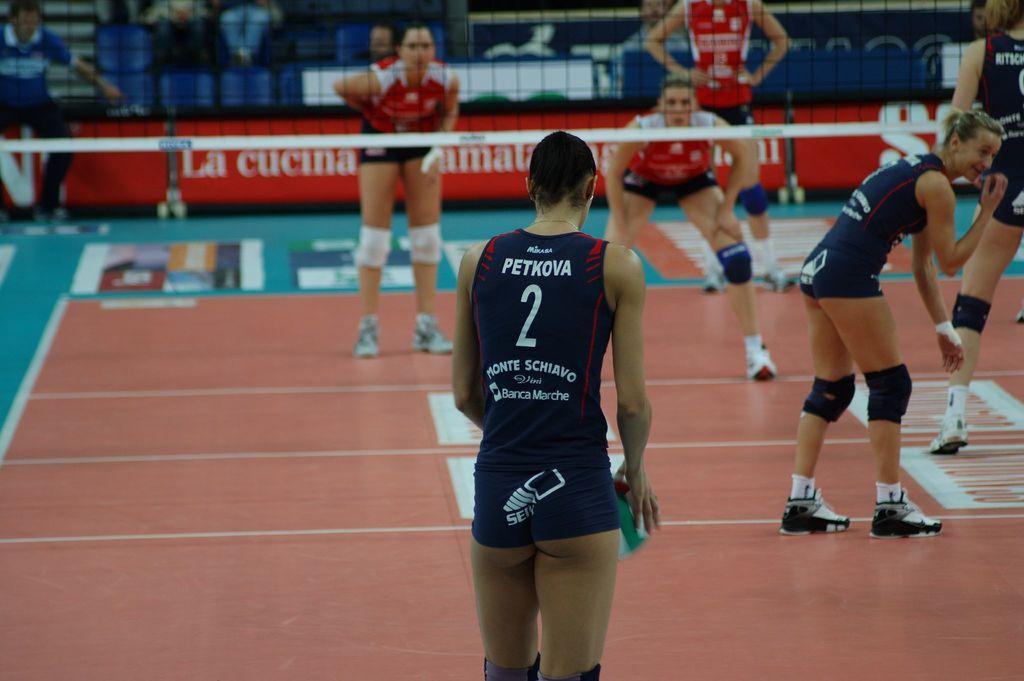Could you give a brief overview of what you see in this image? In this image we can see girls playing a sport in the stadium. There is a net. In the background of the image there is a advertisement board. 